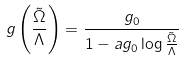Convert formula to latex. <formula><loc_0><loc_0><loc_500><loc_500>g \left ( \frac { \tilde { \Omega } } { \Lambda } \right ) = \frac { g _ { 0 } } { 1 - a g _ { 0 } \log \frac { \tilde { \Omega } } { \Lambda } }</formula> 